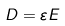Convert formula to latex. <formula><loc_0><loc_0><loc_500><loc_500>D = { \varepsilon } E</formula> 